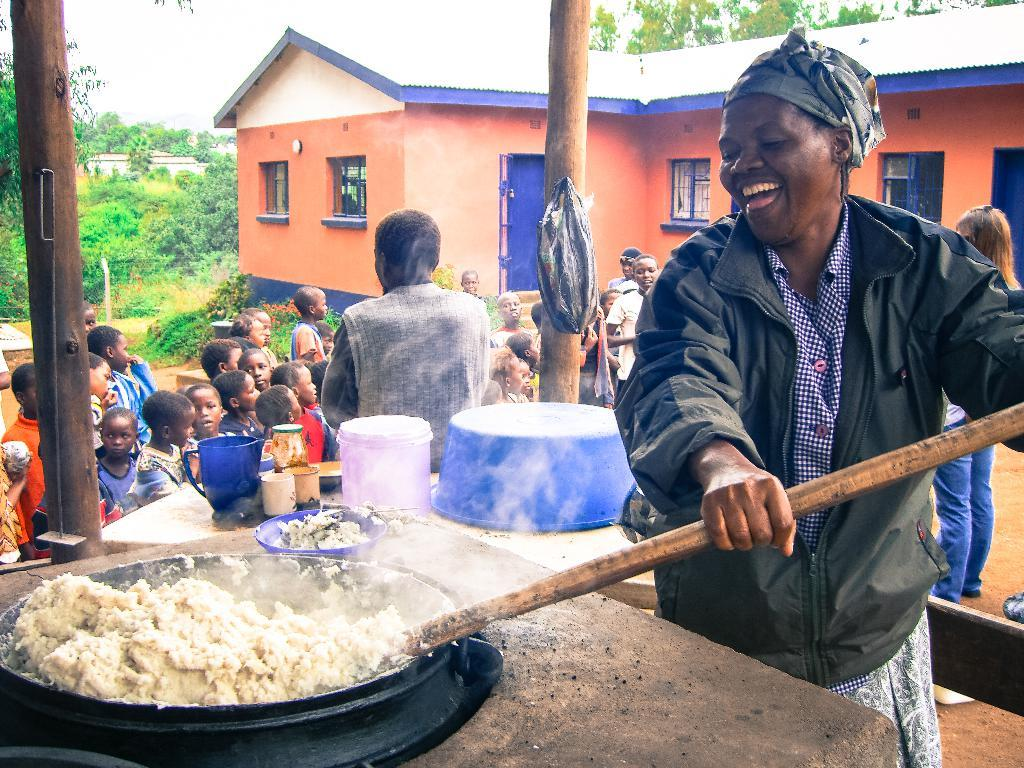What is the person in the image doing? The person in the image is cooking food. What type of containers can be seen in the image? There are bowls, a jug, and a bottle in the image. What items are used for covering or sealing in the image? There are caps in the image. What type of storage or carrying objects are present in the image? There are baskets in the image. What can be seen in the background of the image? There is a group of people, poles, a house, plants, trees, and the sky visible in the background of the image. What type of gold account does the person in the image have? There is no mention of gold or an account in the image, so this information cannot be determined. 